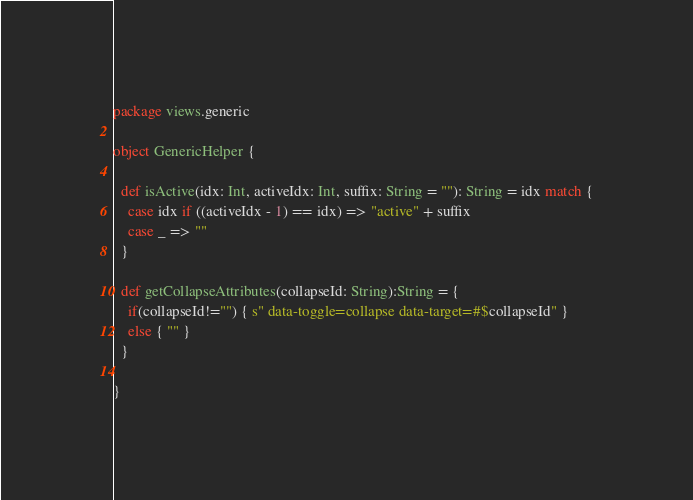<code> <loc_0><loc_0><loc_500><loc_500><_Scala_>package views.generic

object GenericHelper {

  def isActive(idx: Int, activeIdx: Int, suffix: String = ""): String = idx match {
    case idx if ((activeIdx - 1) == idx) => "active" + suffix
    case _ => ""
  }

  def getCollapseAttributes(collapseId: String):String = {
    if(collapseId!="") { s" data-toggle=collapse data-target=#$collapseId" }
    else { "" }
  }

}</code> 